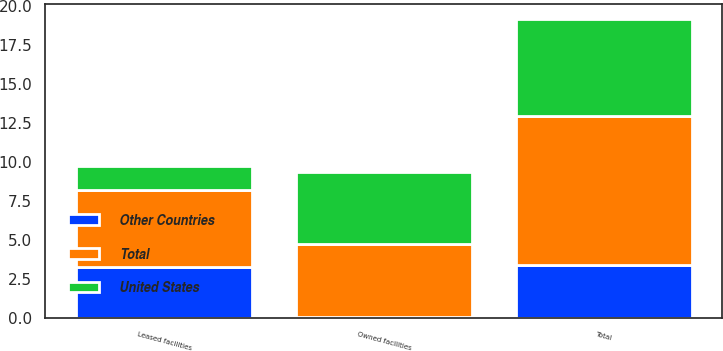Convert chart. <chart><loc_0><loc_0><loc_500><loc_500><stacked_bar_chart><ecel><fcel>Owned facilities<fcel>Leased facilities<fcel>Total<nl><fcel>United States<fcel>4.6<fcel>1.6<fcel>6.2<nl><fcel>Other Countries<fcel>0.1<fcel>3.3<fcel>3.4<nl><fcel>Total<fcel>4.7<fcel>4.9<fcel>9.6<nl></chart> 